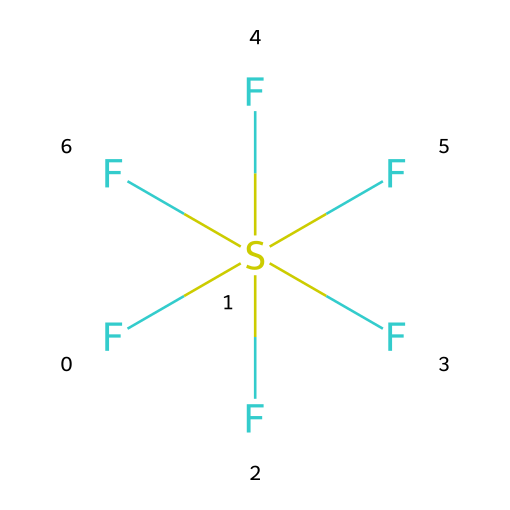What is the molecular formula for sulfur hexafluoride? The SMILES notation indicates the presence of one sulfur atom and six fluorine atoms. By counting, we find that the molecular formula is SF6.
Answer: SF6 How many fluorine atoms are there in this compound? The chemical structure shows a sulfur atom bonded to six fluorine atoms. Therefore, the count of fluorine atoms is six.
Answer: six What is the hybridization of the sulfur atom? Sulfur in this structure is surrounded by six fluorine atoms, which means it has six equivalent bonding pairs. Thus, the hybridization is sp3d2.
Answer: sp3d2 What type of bond connects sulfur and fluorine in this compound? The connections between sulfur and fluorine are single covalent bonds, as indicated by the SMILES representation.
Answer: single covalent Why is sulfur hexafluoride considered a hypervalent compound? Sulfur hexafluoride has more than four bonds associated with the sulfur atom, specifically six in this case. The ability of sulfur to expand its octet leads to this classification.
Answer: hypervalent What is the significance of hypervalency in sulfur hexafluoride's stability? The hypervalency allows sulfur to accommodate more than eight electrons, resulting in a stable structure even with six bond formations. This increased electron count contributes to its stability.
Answer: stability Is sulfur hexafluoride a gas at room temperature? Given the molecular characteristics and its properties, sulfur hexafluoride is indeed a gas at room temperature.
Answer: gas 